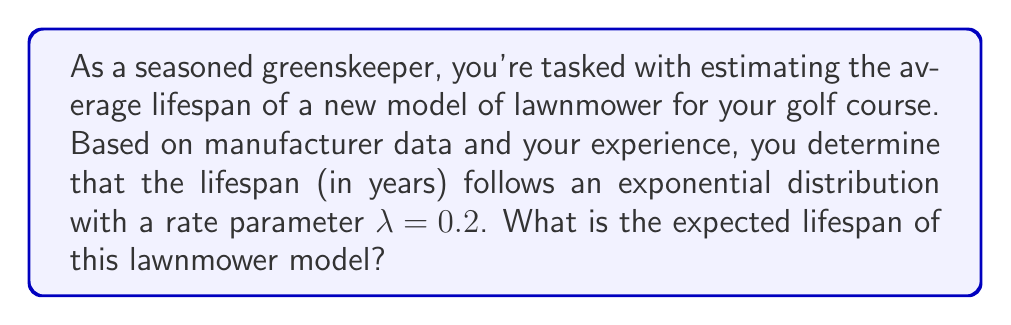Solve this math problem. Let's approach this step-by-step:

1) The exponential distribution is often used to model the lifetime of equipment. Its probability density function is given by:

   $$f(x) = λe^{-λx}, \quad x \geq 0$$

2) For an exponential distribution, the expected value (mean) is given by:

   $$E[X] = \frac{1}{λ}$$

3) In this case, we're given that λ = 0.2. Let's substitute this into our formula:

   $$E[X] = \frac{1}{0.2}$$

4) Now, let's calculate:

   $$E[X] = 5$$

5) Therefore, the expected lifespan of the lawnmower is 5 years.

This means that, on average, you can expect each lawnmower of this model to last about 5 years before needing replacement. However, keep in mind that some may last longer and some shorter due to the nature of probability distributions.
Answer: 5 years 